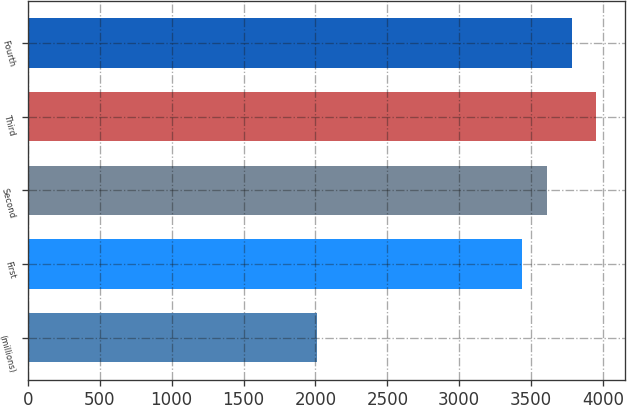Convert chart to OTSL. <chart><loc_0><loc_0><loc_500><loc_500><bar_chart><fcel>(millions)<fcel>First<fcel>Second<fcel>Third<fcel>Fourth<nl><fcel>2012<fcel>3440<fcel>3610.8<fcel>3952.4<fcel>3781.6<nl></chart> 